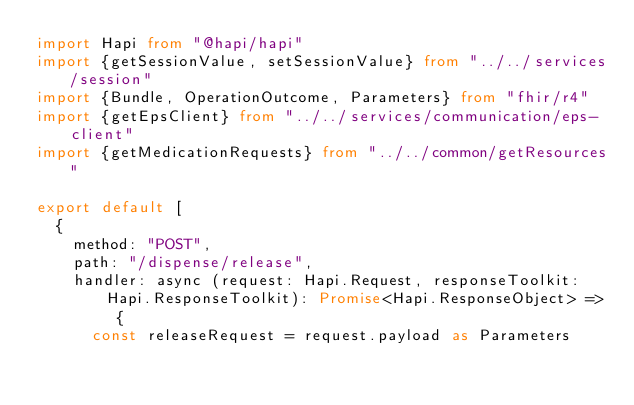Convert code to text. <code><loc_0><loc_0><loc_500><loc_500><_TypeScript_>import Hapi from "@hapi/hapi"
import {getSessionValue, setSessionValue} from "../../services/session"
import {Bundle, OperationOutcome, Parameters} from "fhir/r4"
import {getEpsClient} from "../../services/communication/eps-client"
import {getMedicationRequests} from "../../common/getResources"

export default [
  {
    method: "POST",
    path: "/dispense/release",
    handler: async (request: Hapi.Request, responseToolkit: Hapi.ResponseToolkit): Promise<Hapi.ResponseObject> => {
      const releaseRequest = request.payload as Parameters</code> 